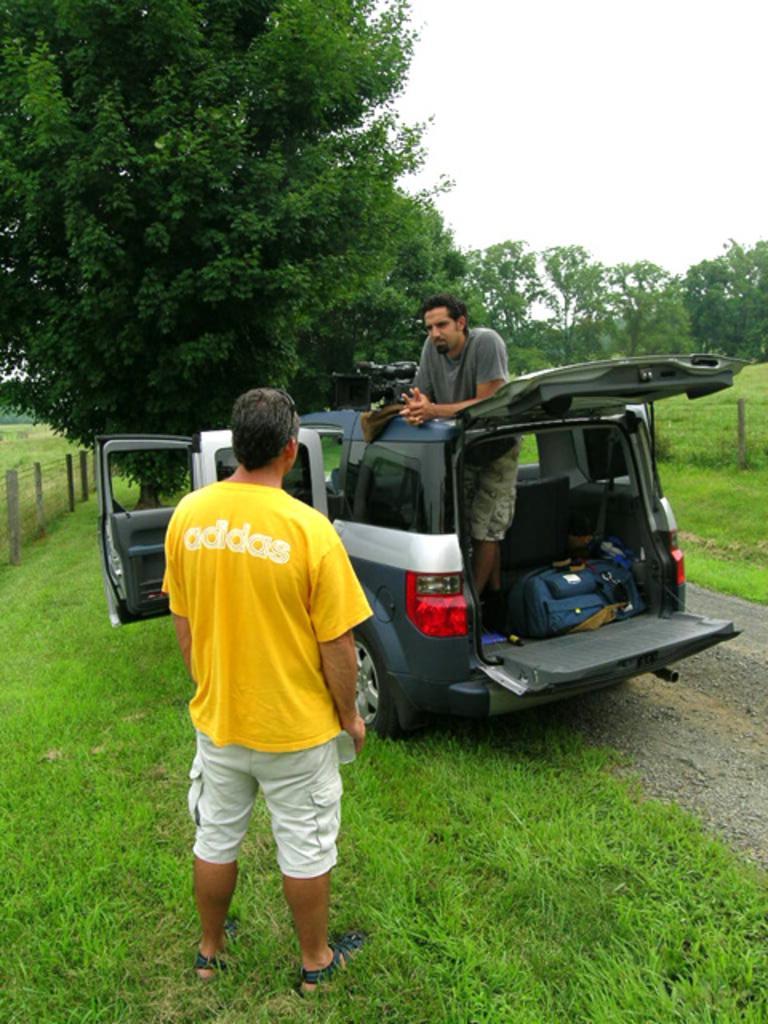Describe this image in one or two sentences. In front of the picture, the man in yellow T-shirt is standing on the grass. At the bottom of the picture, we see grass. In front of him, we see the man in grey T-shirt is standing in the car. Beside him, we see a blue color bag is placed in the car. On either side of the picture, we see a fence. There are trees in the background. In the right top of the picture, we see the sky. 